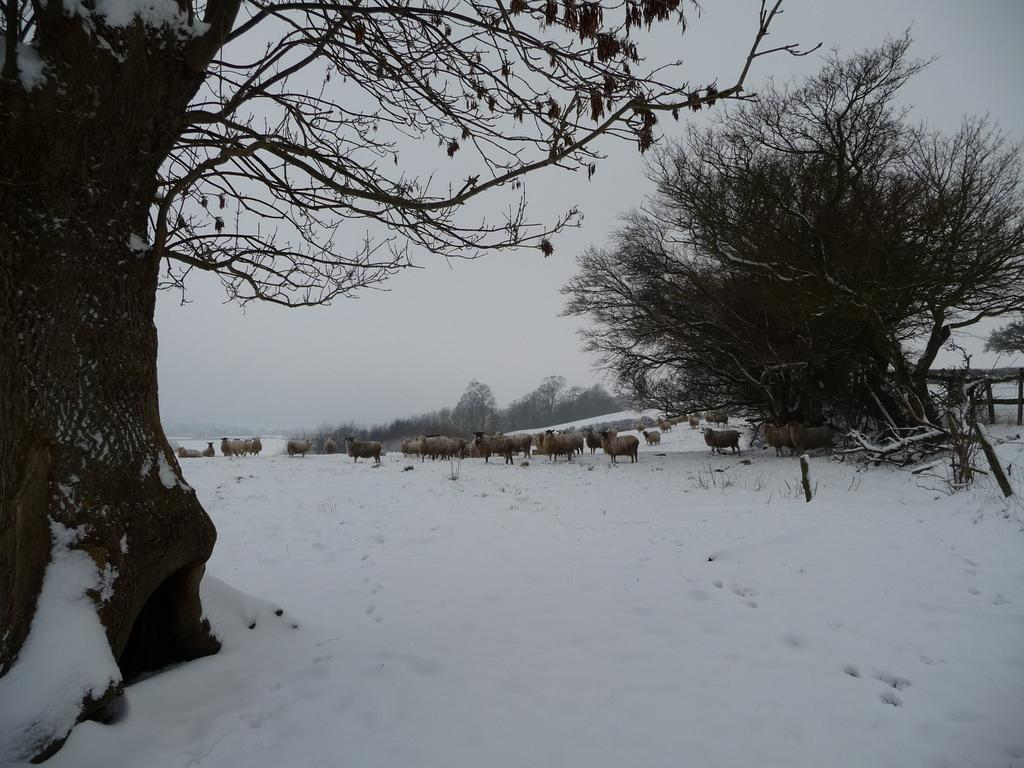What is the main subject of the image? There is a group of animals in the image. What is the terrain like where the animals are standing? The animals are standing on snow. What type of vegetation can be seen in the image? There are trees visible in the image. What is visible in the background of the image? The sky is visible in the background of the image. What type of station can be seen in the image? There is no station present in the image; it features a group of animals standing on snow with trees and the sky visible in the background. How much growth can be observed in the trees in the image? The provided facts do not give information about the growth of the trees, only their presence. 